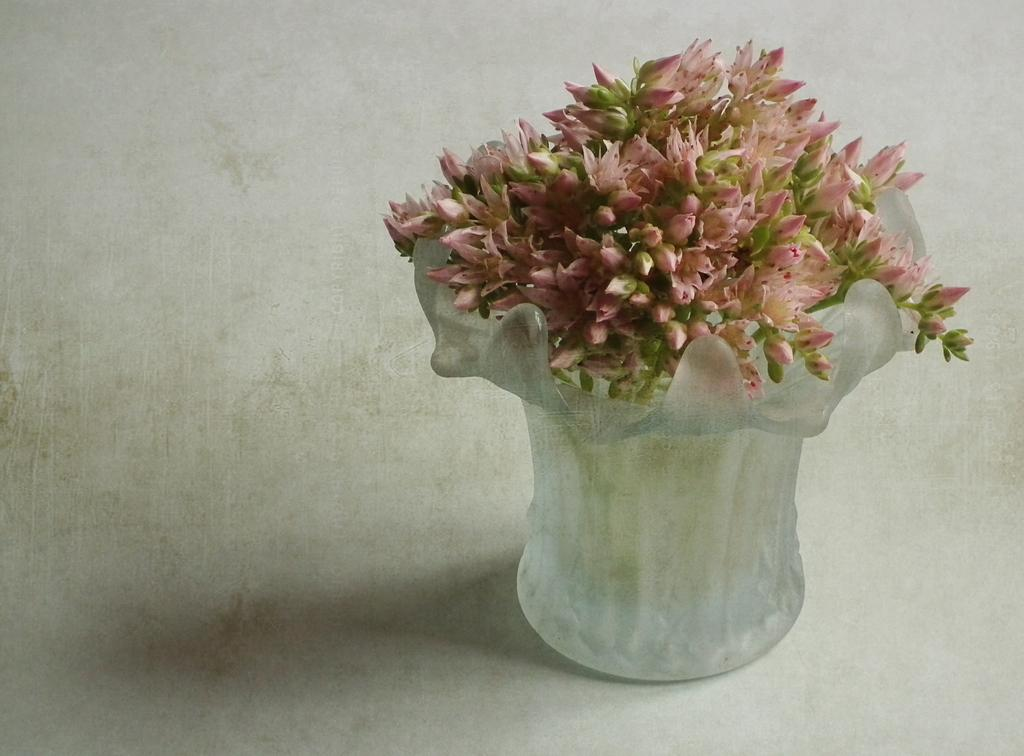What is in the jar that is visible in the image? The jar contains flowers. Where is the jar with flowers located in the image? The jar with flowers is on the floor. Is the existence of a judge in the image confirmed? There is no mention of a judge in the image, so we cannot confirm its existence. Can you tell me how many ladybugs are present in the image? There is no mention of ladybugs in the image, so we cannot determine their presence or quantity. 